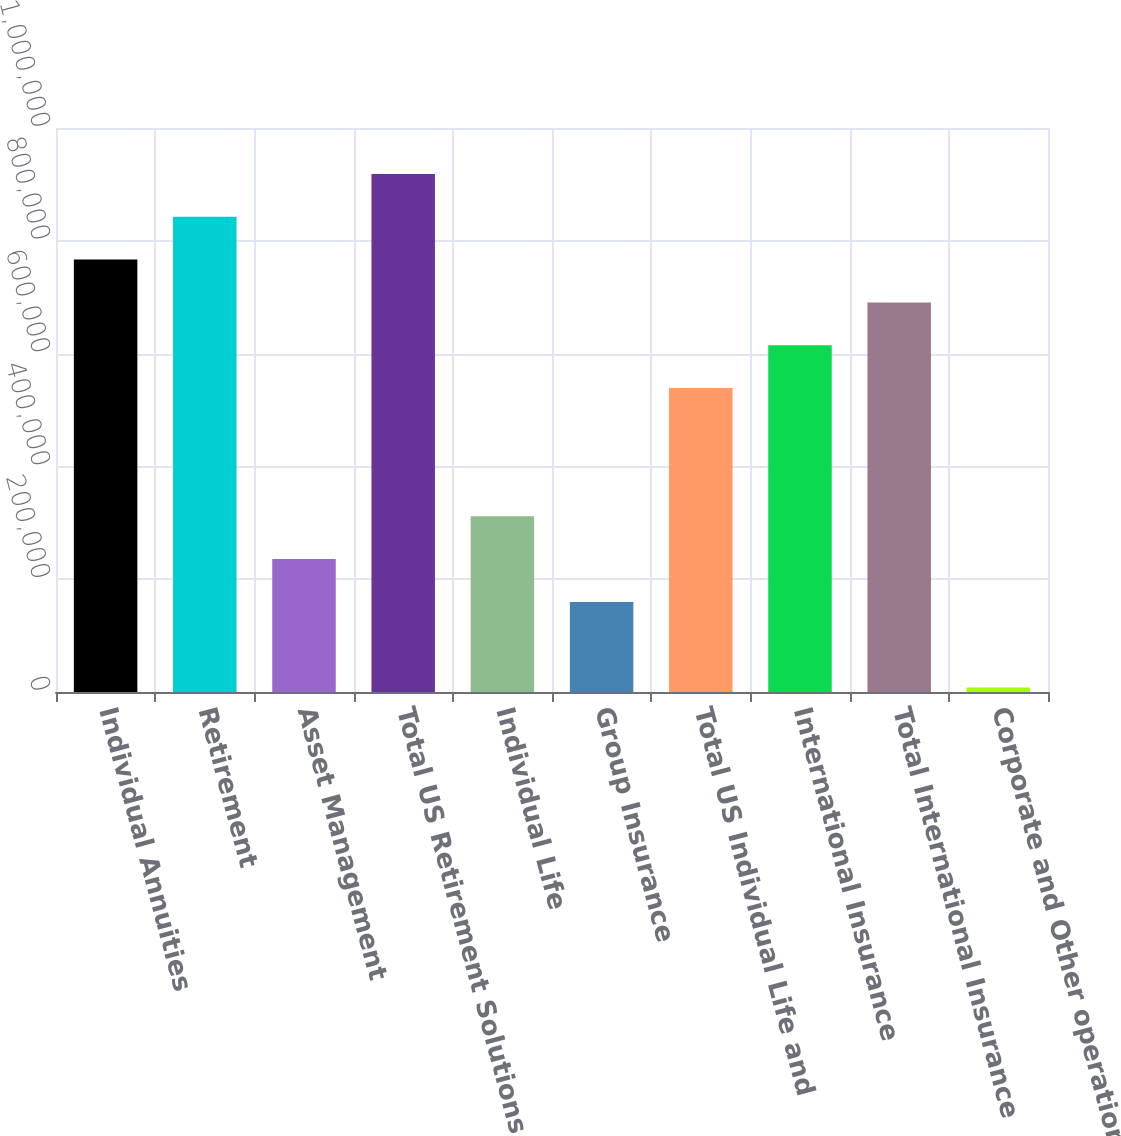Convert chart to OTSL. <chart><loc_0><loc_0><loc_500><loc_500><bar_chart><fcel>Individual Annuities<fcel>Retirement<fcel>Asset Management<fcel>Total US Retirement Solutions<fcel>Individual Life<fcel>Group Insurance<fcel>Total US Individual Life and<fcel>International Insurance<fcel>Total International Insurance<fcel>Corporate and Other operations<nl><fcel>766655<fcel>842519<fcel>235606<fcel>918383<fcel>311470<fcel>159741<fcel>539062<fcel>614927<fcel>690791<fcel>8013<nl></chart> 